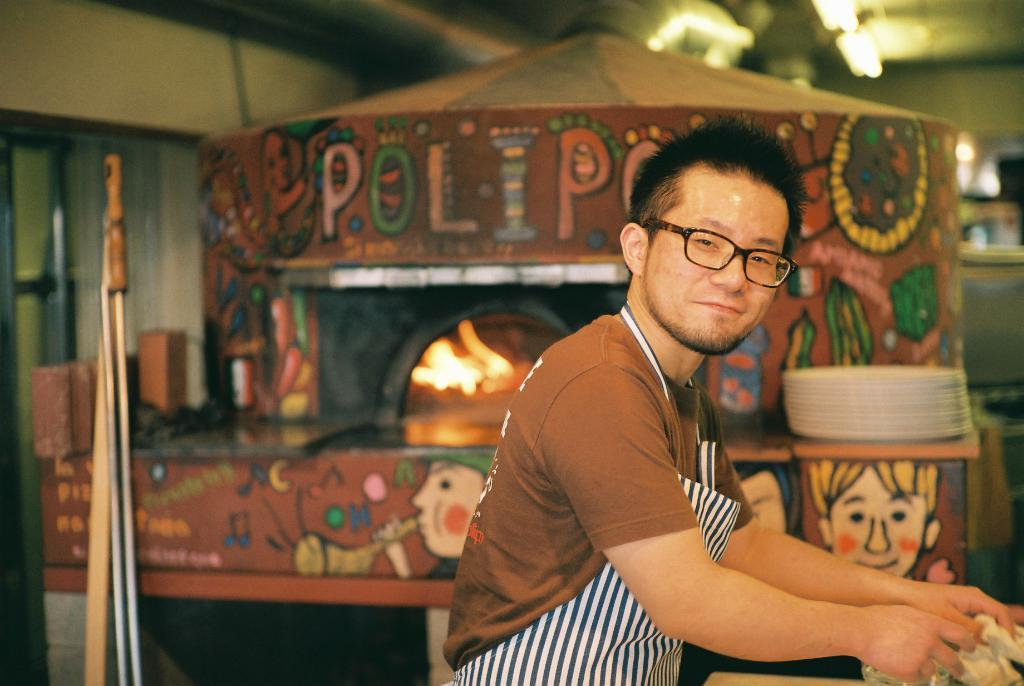What is the man in the image doing? The man is standing in the image. What is the man's facial expression? The man is smiling in the image. What accessories is the man wearing? The man is wearing spectacles and an apron in the image. What type of shirt is the man wearing? The man is wearing a t-shirt in the image. What can be seen in the background of the image? There are planes, fire, and other objects in the background of the image. What type of cat can be seen in the image? There is no cat present in the image. What is the man's tail doing in the image? The man does not have a tail, as humans do not have tails. 